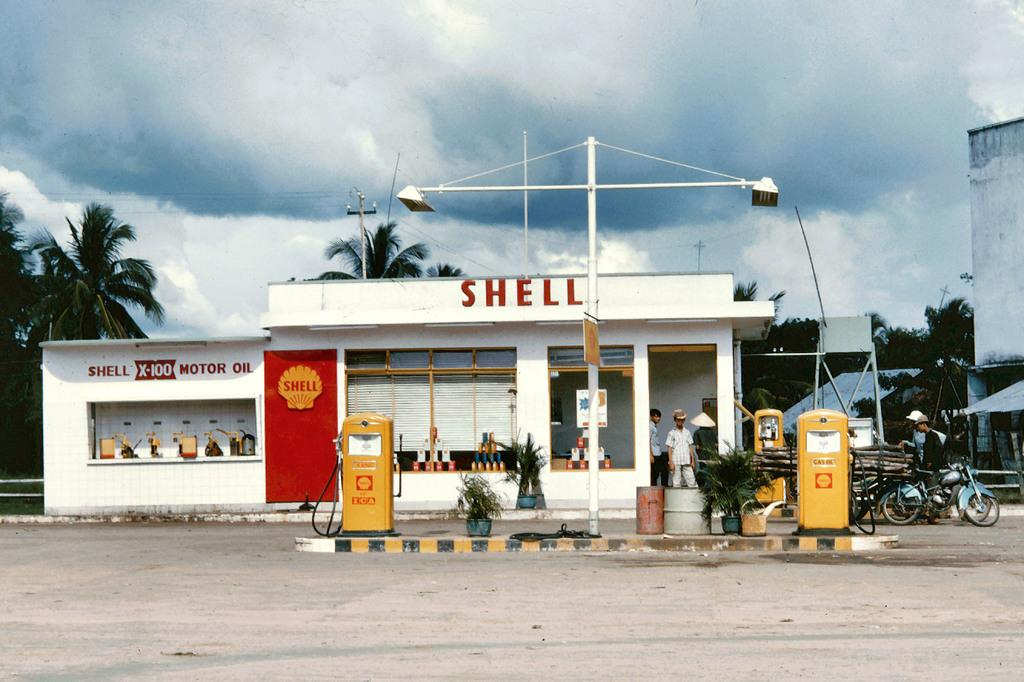What is the main structure in the image? There is a petrol pump in the image. What can be seen in the background of the image? There are trees and plants in the image. What type of lighting is present in the image? There is a street light in the image. What type of structure is visible in the image? There is a building in the image. What note is the person singing in the image? There is no person singing in the image; it features a petrol pump, trees and plants, a street light, and a building. 